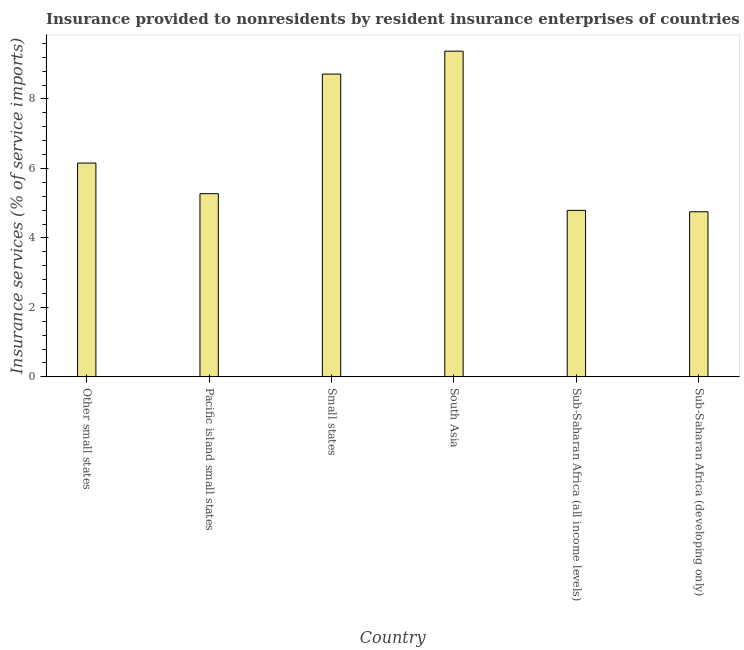What is the title of the graph?
Your answer should be very brief. Insurance provided to nonresidents by resident insurance enterprises of countries in 2010. What is the label or title of the Y-axis?
Your answer should be compact. Insurance services (% of service imports). What is the insurance and financial services in Small states?
Your response must be concise. 8.72. Across all countries, what is the maximum insurance and financial services?
Give a very brief answer. 9.38. Across all countries, what is the minimum insurance and financial services?
Your answer should be compact. 4.75. In which country was the insurance and financial services minimum?
Keep it short and to the point. Sub-Saharan Africa (developing only). What is the sum of the insurance and financial services?
Your response must be concise. 39.07. What is the difference between the insurance and financial services in South Asia and Sub-Saharan Africa (developing only)?
Your answer should be compact. 4.62. What is the average insurance and financial services per country?
Keep it short and to the point. 6.51. What is the median insurance and financial services?
Ensure brevity in your answer.  5.71. What is the ratio of the insurance and financial services in Small states to that in Sub-Saharan Africa (developing only)?
Offer a terse response. 1.83. Is the difference between the insurance and financial services in South Asia and Sub-Saharan Africa (developing only) greater than the difference between any two countries?
Ensure brevity in your answer.  Yes. What is the difference between the highest and the second highest insurance and financial services?
Offer a terse response. 0.66. Is the sum of the insurance and financial services in South Asia and Sub-Saharan Africa (all income levels) greater than the maximum insurance and financial services across all countries?
Keep it short and to the point. Yes. What is the difference between the highest and the lowest insurance and financial services?
Make the answer very short. 4.62. What is the Insurance services (% of service imports) in Other small states?
Provide a succinct answer. 6.15. What is the Insurance services (% of service imports) in Pacific island small states?
Offer a very short reply. 5.27. What is the Insurance services (% of service imports) in Small states?
Provide a succinct answer. 8.72. What is the Insurance services (% of service imports) in South Asia?
Offer a terse response. 9.38. What is the Insurance services (% of service imports) in Sub-Saharan Africa (all income levels)?
Your response must be concise. 4.79. What is the Insurance services (% of service imports) in Sub-Saharan Africa (developing only)?
Your answer should be very brief. 4.75. What is the difference between the Insurance services (% of service imports) in Other small states and Pacific island small states?
Make the answer very short. 0.88. What is the difference between the Insurance services (% of service imports) in Other small states and Small states?
Offer a very short reply. -2.56. What is the difference between the Insurance services (% of service imports) in Other small states and South Asia?
Keep it short and to the point. -3.22. What is the difference between the Insurance services (% of service imports) in Other small states and Sub-Saharan Africa (all income levels)?
Your answer should be very brief. 1.36. What is the difference between the Insurance services (% of service imports) in Other small states and Sub-Saharan Africa (developing only)?
Make the answer very short. 1.4. What is the difference between the Insurance services (% of service imports) in Pacific island small states and Small states?
Offer a very short reply. -3.44. What is the difference between the Insurance services (% of service imports) in Pacific island small states and South Asia?
Offer a terse response. -4.1. What is the difference between the Insurance services (% of service imports) in Pacific island small states and Sub-Saharan Africa (all income levels)?
Make the answer very short. 0.48. What is the difference between the Insurance services (% of service imports) in Pacific island small states and Sub-Saharan Africa (developing only)?
Provide a succinct answer. 0.52. What is the difference between the Insurance services (% of service imports) in Small states and South Asia?
Ensure brevity in your answer.  -0.66. What is the difference between the Insurance services (% of service imports) in Small states and Sub-Saharan Africa (all income levels)?
Provide a short and direct response. 3.92. What is the difference between the Insurance services (% of service imports) in Small states and Sub-Saharan Africa (developing only)?
Offer a very short reply. 3.96. What is the difference between the Insurance services (% of service imports) in South Asia and Sub-Saharan Africa (all income levels)?
Make the answer very short. 4.58. What is the difference between the Insurance services (% of service imports) in South Asia and Sub-Saharan Africa (developing only)?
Keep it short and to the point. 4.62. What is the difference between the Insurance services (% of service imports) in Sub-Saharan Africa (all income levels) and Sub-Saharan Africa (developing only)?
Offer a very short reply. 0.04. What is the ratio of the Insurance services (% of service imports) in Other small states to that in Pacific island small states?
Your response must be concise. 1.17. What is the ratio of the Insurance services (% of service imports) in Other small states to that in Small states?
Give a very brief answer. 0.71. What is the ratio of the Insurance services (% of service imports) in Other small states to that in South Asia?
Keep it short and to the point. 0.66. What is the ratio of the Insurance services (% of service imports) in Other small states to that in Sub-Saharan Africa (all income levels)?
Keep it short and to the point. 1.28. What is the ratio of the Insurance services (% of service imports) in Other small states to that in Sub-Saharan Africa (developing only)?
Give a very brief answer. 1.29. What is the ratio of the Insurance services (% of service imports) in Pacific island small states to that in Small states?
Your answer should be very brief. 0.6. What is the ratio of the Insurance services (% of service imports) in Pacific island small states to that in South Asia?
Ensure brevity in your answer.  0.56. What is the ratio of the Insurance services (% of service imports) in Pacific island small states to that in Sub-Saharan Africa (all income levels)?
Offer a terse response. 1.1. What is the ratio of the Insurance services (% of service imports) in Pacific island small states to that in Sub-Saharan Africa (developing only)?
Keep it short and to the point. 1.11. What is the ratio of the Insurance services (% of service imports) in Small states to that in South Asia?
Keep it short and to the point. 0.93. What is the ratio of the Insurance services (% of service imports) in Small states to that in Sub-Saharan Africa (all income levels)?
Provide a short and direct response. 1.82. What is the ratio of the Insurance services (% of service imports) in Small states to that in Sub-Saharan Africa (developing only)?
Keep it short and to the point. 1.83. What is the ratio of the Insurance services (% of service imports) in South Asia to that in Sub-Saharan Africa (all income levels)?
Your answer should be compact. 1.96. What is the ratio of the Insurance services (% of service imports) in South Asia to that in Sub-Saharan Africa (developing only)?
Give a very brief answer. 1.97. What is the ratio of the Insurance services (% of service imports) in Sub-Saharan Africa (all income levels) to that in Sub-Saharan Africa (developing only)?
Offer a very short reply. 1.01. 